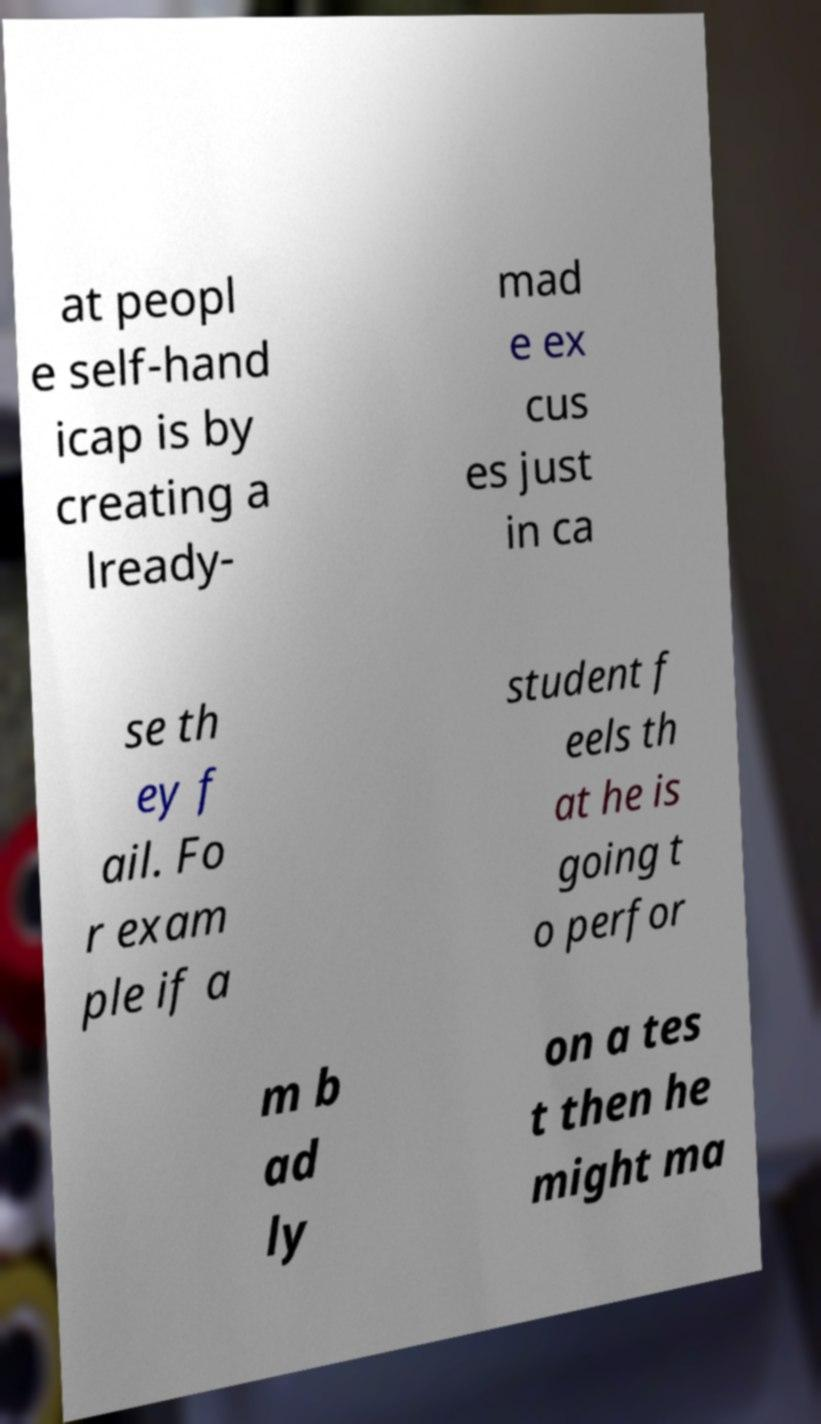Please identify and transcribe the text found in this image. at peopl e self-hand icap is by creating a lready- mad e ex cus es just in ca se th ey f ail. Fo r exam ple if a student f eels th at he is going t o perfor m b ad ly on a tes t then he might ma 